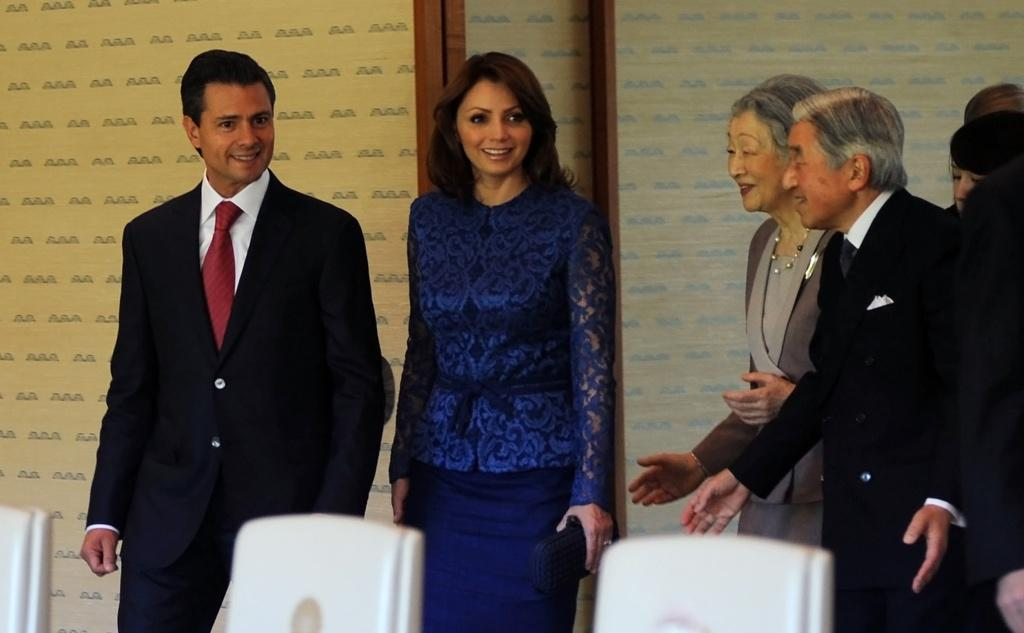How many people are in the image? There are two persons standing and smiling in the image. What are the people in the image doing? The people are standing and smiling. What type of furniture is present in the image? There are chairs in the image. What can be seen in the background of the image? There is a wall in the background of the image. How many groups of people are in the image? There is a group of people standing in the image. What type of clover is growing on the wall in the image? There is no clover present in the image; it only features a wall in the background. 